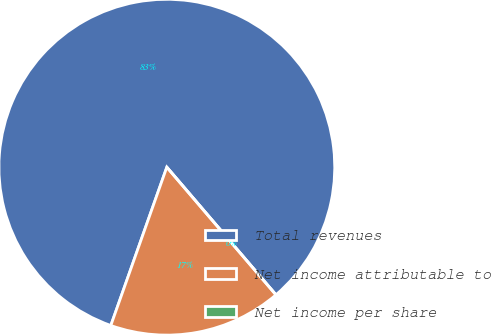Convert chart to OTSL. <chart><loc_0><loc_0><loc_500><loc_500><pie_chart><fcel>Total revenues<fcel>Net income attributable to<fcel>Net income per share<nl><fcel>83.33%<fcel>16.67%<fcel>0.0%<nl></chart> 